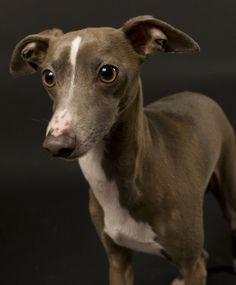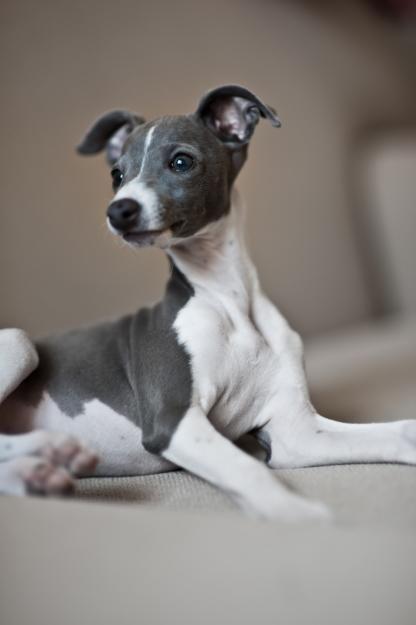The first image is the image on the left, the second image is the image on the right. Given the left and right images, does the statement "At least one dog is a solid color with no patches of white." hold true? Answer yes or no. No. The first image is the image on the left, the second image is the image on the right. Considering the images on both sides, is "The right image shows a gray-and-white dog that is craning its neck." valid? Answer yes or no. Yes. 